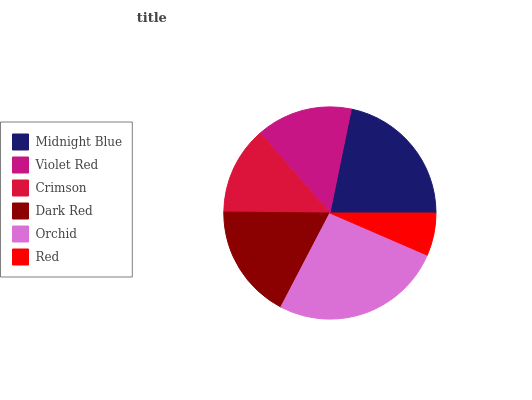Is Red the minimum?
Answer yes or no. Yes. Is Orchid the maximum?
Answer yes or no. Yes. Is Violet Red the minimum?
Answer yes or no. No. Is Violet Red the maximum?
Answer yes or no. No. Is Midnight Blue greater than Violet Red?
Answer yes or no. Yes. Is Violet Red less than Midnight Blue?
Answer yes or no. Yes. Is Violet Red greater than Midnight Blue?
Answer yes or no. No. Is Midnight Blue less than Violet Red?
Answer yes or no. No. Is Dark Red the high median?
Answer yes or no. Yes. Is Violet Red the low median?
Answer yes or no. Yes. Is Red the high median?
Answer yes or no. No. Is Midnight Blue the low median?
Answer yes or no. No. 